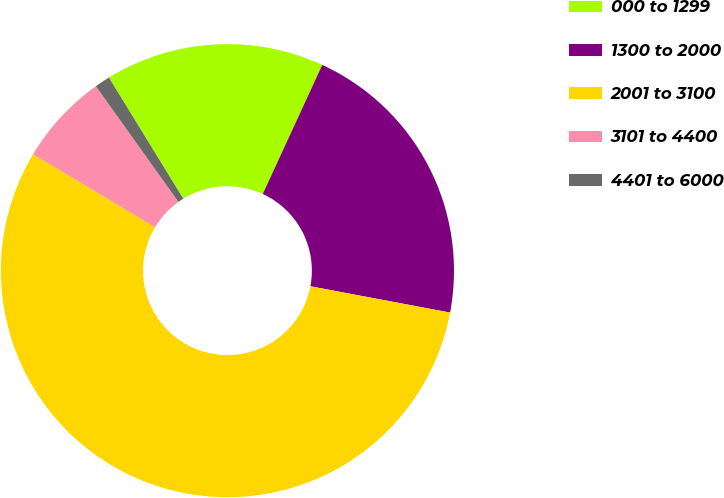Convert chart to OTSL. <chart><loc_0><loc_0><loc_500><loc_500><pie_chart><fcel>000 to 1299<fcel>1300 to 2000<fcel>2001 to 3100<fcel>3101 to 4400<fcel>4401 to 6000<nl><fcel>15.64%<fcel>21.09%<fcel>55.63%<fcel>6.55%<fcel>1.1%<nl></chart> 